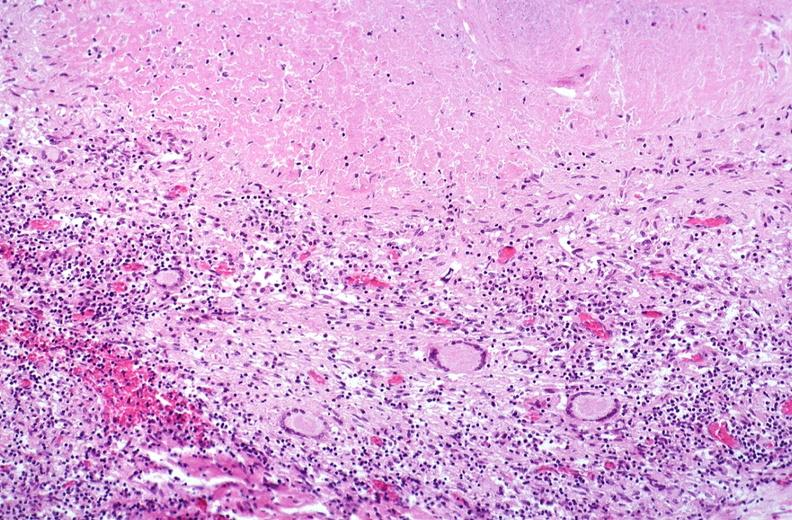does this image show lung, mycobacterium tuberculosis, granulomas and giant cells?
Answer the question using a single word or phrase. Yes 